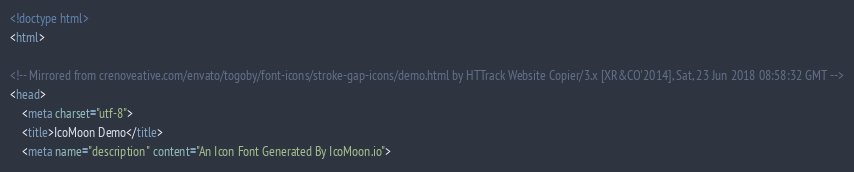Convert code to text. <code><loc_0><loc_0><loc_500><loc_500><_HTML_><!doctype html>
<html>

<!-- Mirrored from crenoveative.com/envato/togoby/font-icons/stroke-gap-icons/demo.html by HTTrack Website Copier/3.x [XR&CO'2014], Sat, 23 Jun 2018 08:58:32 GMT -->
<head>
	<meta charset="utf-8">
	<title>IcoMoon Demo</title>
	<meta name="description" content="An Icon Font Generated By IcoMoon.io"></code> 